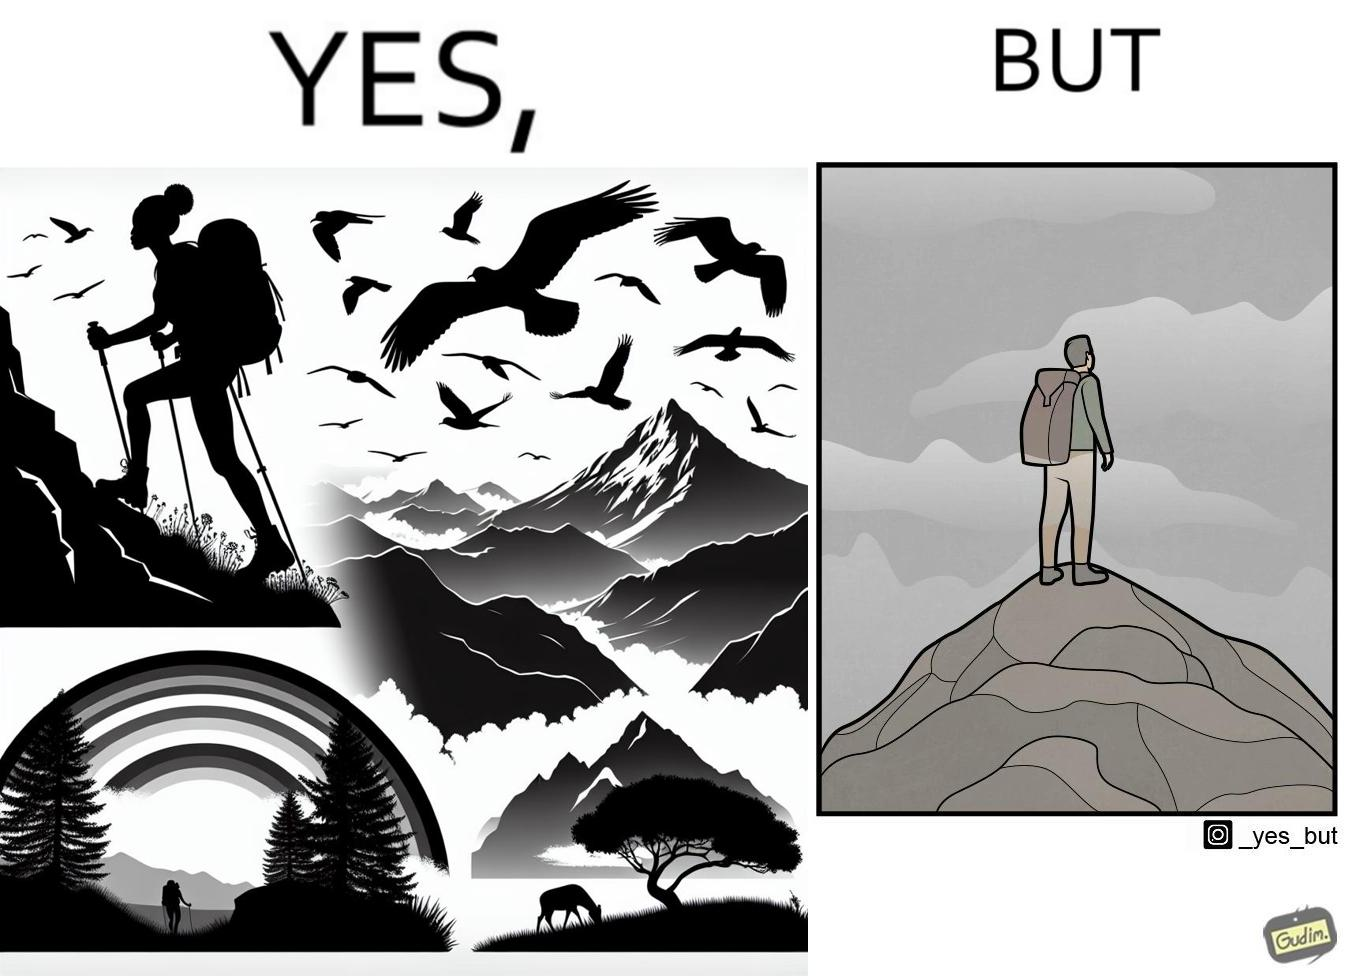Does this image contain satire or humor? Yes, this image is satirical. 